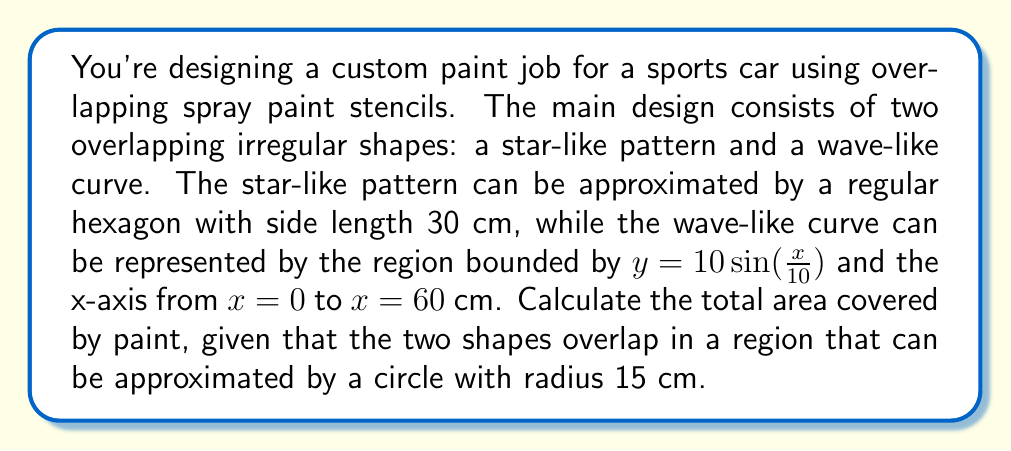Teach me how to tackle this problem. Let's break this down step by step:

1) Area of the star-like pattern (hexagon):
   The area of a regular hexagon is given by $A = \frac{3\sqrt{3}}{2}s^2$, where $s$ is the side length.
   $$A_{hexagon} = \frac{3\sqrt{3}}{2}(30)^2 = 2338.26 \text{ cm}^2$$

2) Area of the wave-like curve:
   This is the area under the curve $y = 10\sin(\frac{x}{10})$ from 0 to 60.
   We can find this using integration:
   $$A_{wave} = \int_0^{60} 10\sin(\frac{x}{10}) dx = -100\cos(\frac{x}{10})\bigg|_0^{60}$$
   $$= -100(\cos(6) - \cos(0)) = 100(1 - \cos(6)) = 198.43 \text{ cm}^2$$

3) Area of overlap (circle):
   The area of a circle is $A = \pi r^2$
   $$A_{overlap} = \pi(15)^2 = 706.86 \text{ cm}^2$$

4) Total painted area:
   To find the total area, we add the areas of the hexagon and wave, then subtract the overlap:
   $$A_{total} = A_{hexagon} + A_{wave} - A_{overlap}$$
   $$= 2338.26 + 198.43 - 706.86 = 1829.83 \text{ cm}^2$$
Answer: The total area covered by paint is approximately 1829.83 cm². 